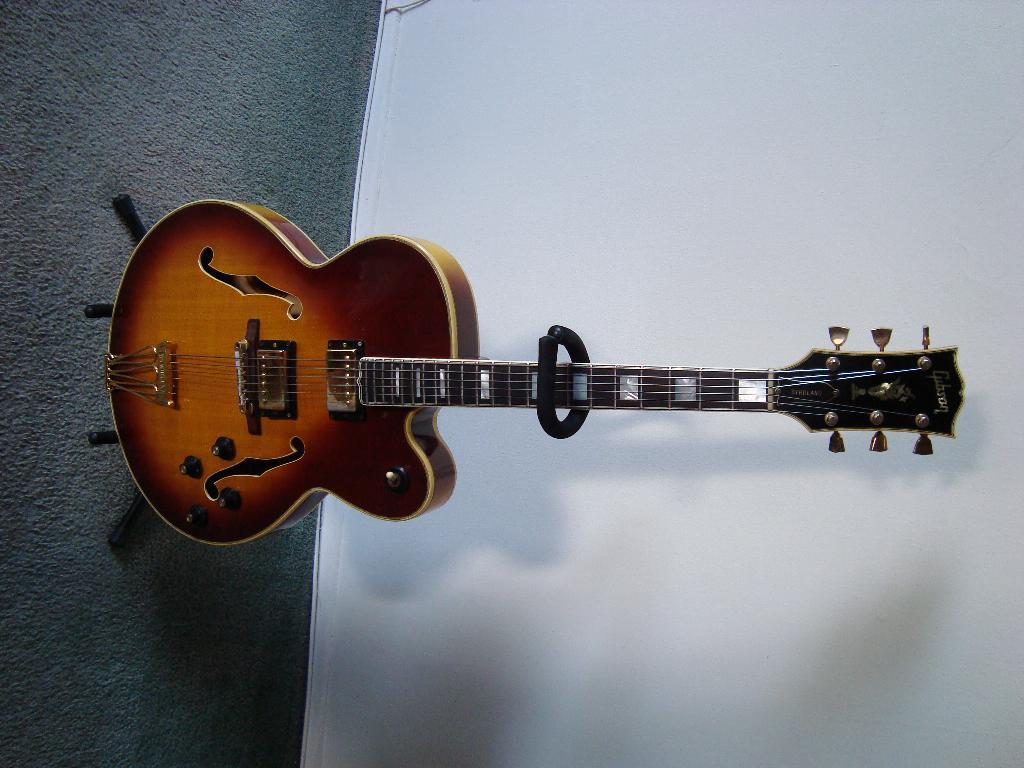What musical instrument is present in the image? There is a guitar in the image. What can be seen in the background of the image? There is a wall in the background of the image. What part of the room is visible in the image? The floor is visible in the image. What type of wren can be seen perched on the guitar in the image? There is no wren present in the image; it only features a guitar and a wall in the background. 